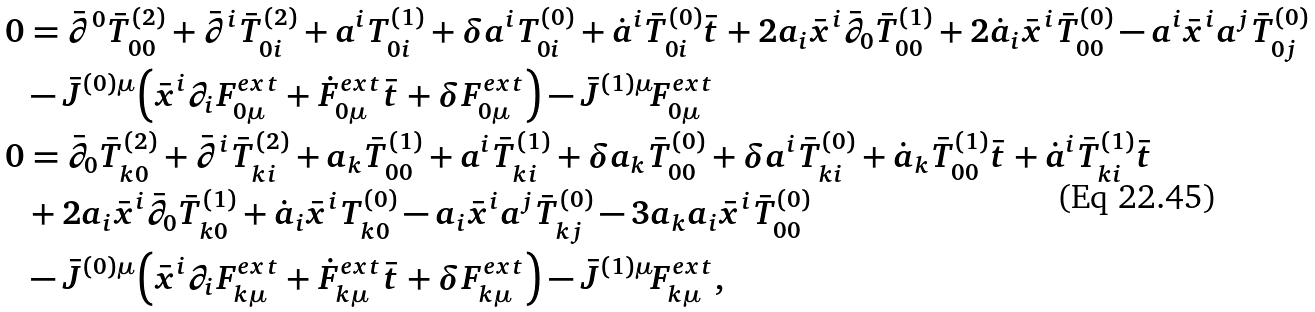Convert formula to latex. <formula><loc_0><loc_0><loc_500><loc_500>0 & = \bar { \partial } ^ { 0 } \bar { T } _ { 0 0 } ^ { ( 2 ) } + \bar { \partial } ^ { i } \bar { T } ^ { ( 2 ) } _ { 0 i } + a ^ { i } T ^ { ( 1 ) } _ { 0 i } + \delta a ^ { i } T ^ { ( 0 ) } _ { 0 i } + \dot { a } ^ { i } \bar { T } _ { 0 i } ^ { ( 0 ) } \bar { t } + 2 a _ { i } \bar { x } ^ { i } \bar { \partial } _ { 0 } \bar { T } ^ { ( 1 ) } _ { 0 0 } + 2 \dot { a } _ { i } \bar { x } ^ { i } \bar { T } ^ { ( 0 ) } _ { 0 0 } - a ^ { i } \bar { x } ^ { i } a ^ { j } \bar { T } ^ { ( 0 ) } _ { 0 j } \\ & - \bar { J } ^ { ( 0 ) \mu } \left ( \bar { x } ^ { i } \partial _ { i } F ^ { e x t } _ { 0 \mu } + \dot { F } ^ { e x t } _ { 0 \mu } \bar { t } + \delta F ^ { e x t } _ { 0 \mu } \right ) - \bar { J } ^ { ( 1 ) \mu } F ^ { e x t } _ { 0 \mu } \\ 0 & = \bar { \partial } _ { 0 } \bar { T } ^ { ( 2 ) } _ { k 0 } + \bar { \partial } ^ { i } \bar { T } ^ { ( 2 ) } _ { k i } + a _ { k } \bar { T } ^ { ( 1 ) } _ { 0 0 } + a ^ { i } \bar { T } ^ { ( 1 ) } _ { k i } + \delta a _ { k } \bar { T } ^ { ( 0 ) } _ { 0 0 } + \delta a ^ { i } \bar { T } ^ { ( 0 ) } _ { k i } + \dot { a } _ { k } \bar { T } ^ { ( 1 ) } _ { 0 0 } \bar { t } + \dot { a } ^ { i } \bar { T } ^ { ( 1 ) } _ { k i } \bar { t } \\ & + 2 a _ { i } \bar { x } ^ { i } \bar { \partial } _ { 0 } \bar { T } ^ { ( 1 ) } _ { k 0 } + \dot { a } _ { i } \bar { x } ^ { i } T ^ { ( 0 ) } _ { k 0 } - a _ { i } \bar { x } ^ { i } a ^ { j } \bar { T } ^ { ( 0 ) } _ { k j } - 3 a _ { k } a _ { i } \bar { x } ^ { i } \bar { T } ^ { ( 0 ) } _ { 0 0 } \\ & - \bar { J } ^ { ( 0 ) \mu } \left ( \bar { x } ^ { i } \partial _ { i } F ^ { e x t } _ { k \mu } + \dot { F } ^ { e x t } _ { k \mu } \bar { t } + \delta F ^ { e x t } _ { k \mu } \right ) - \bar { J } ^ { ( 1 ) \mu } F ^ { e x t } _ { k \mu } ,</formula> 